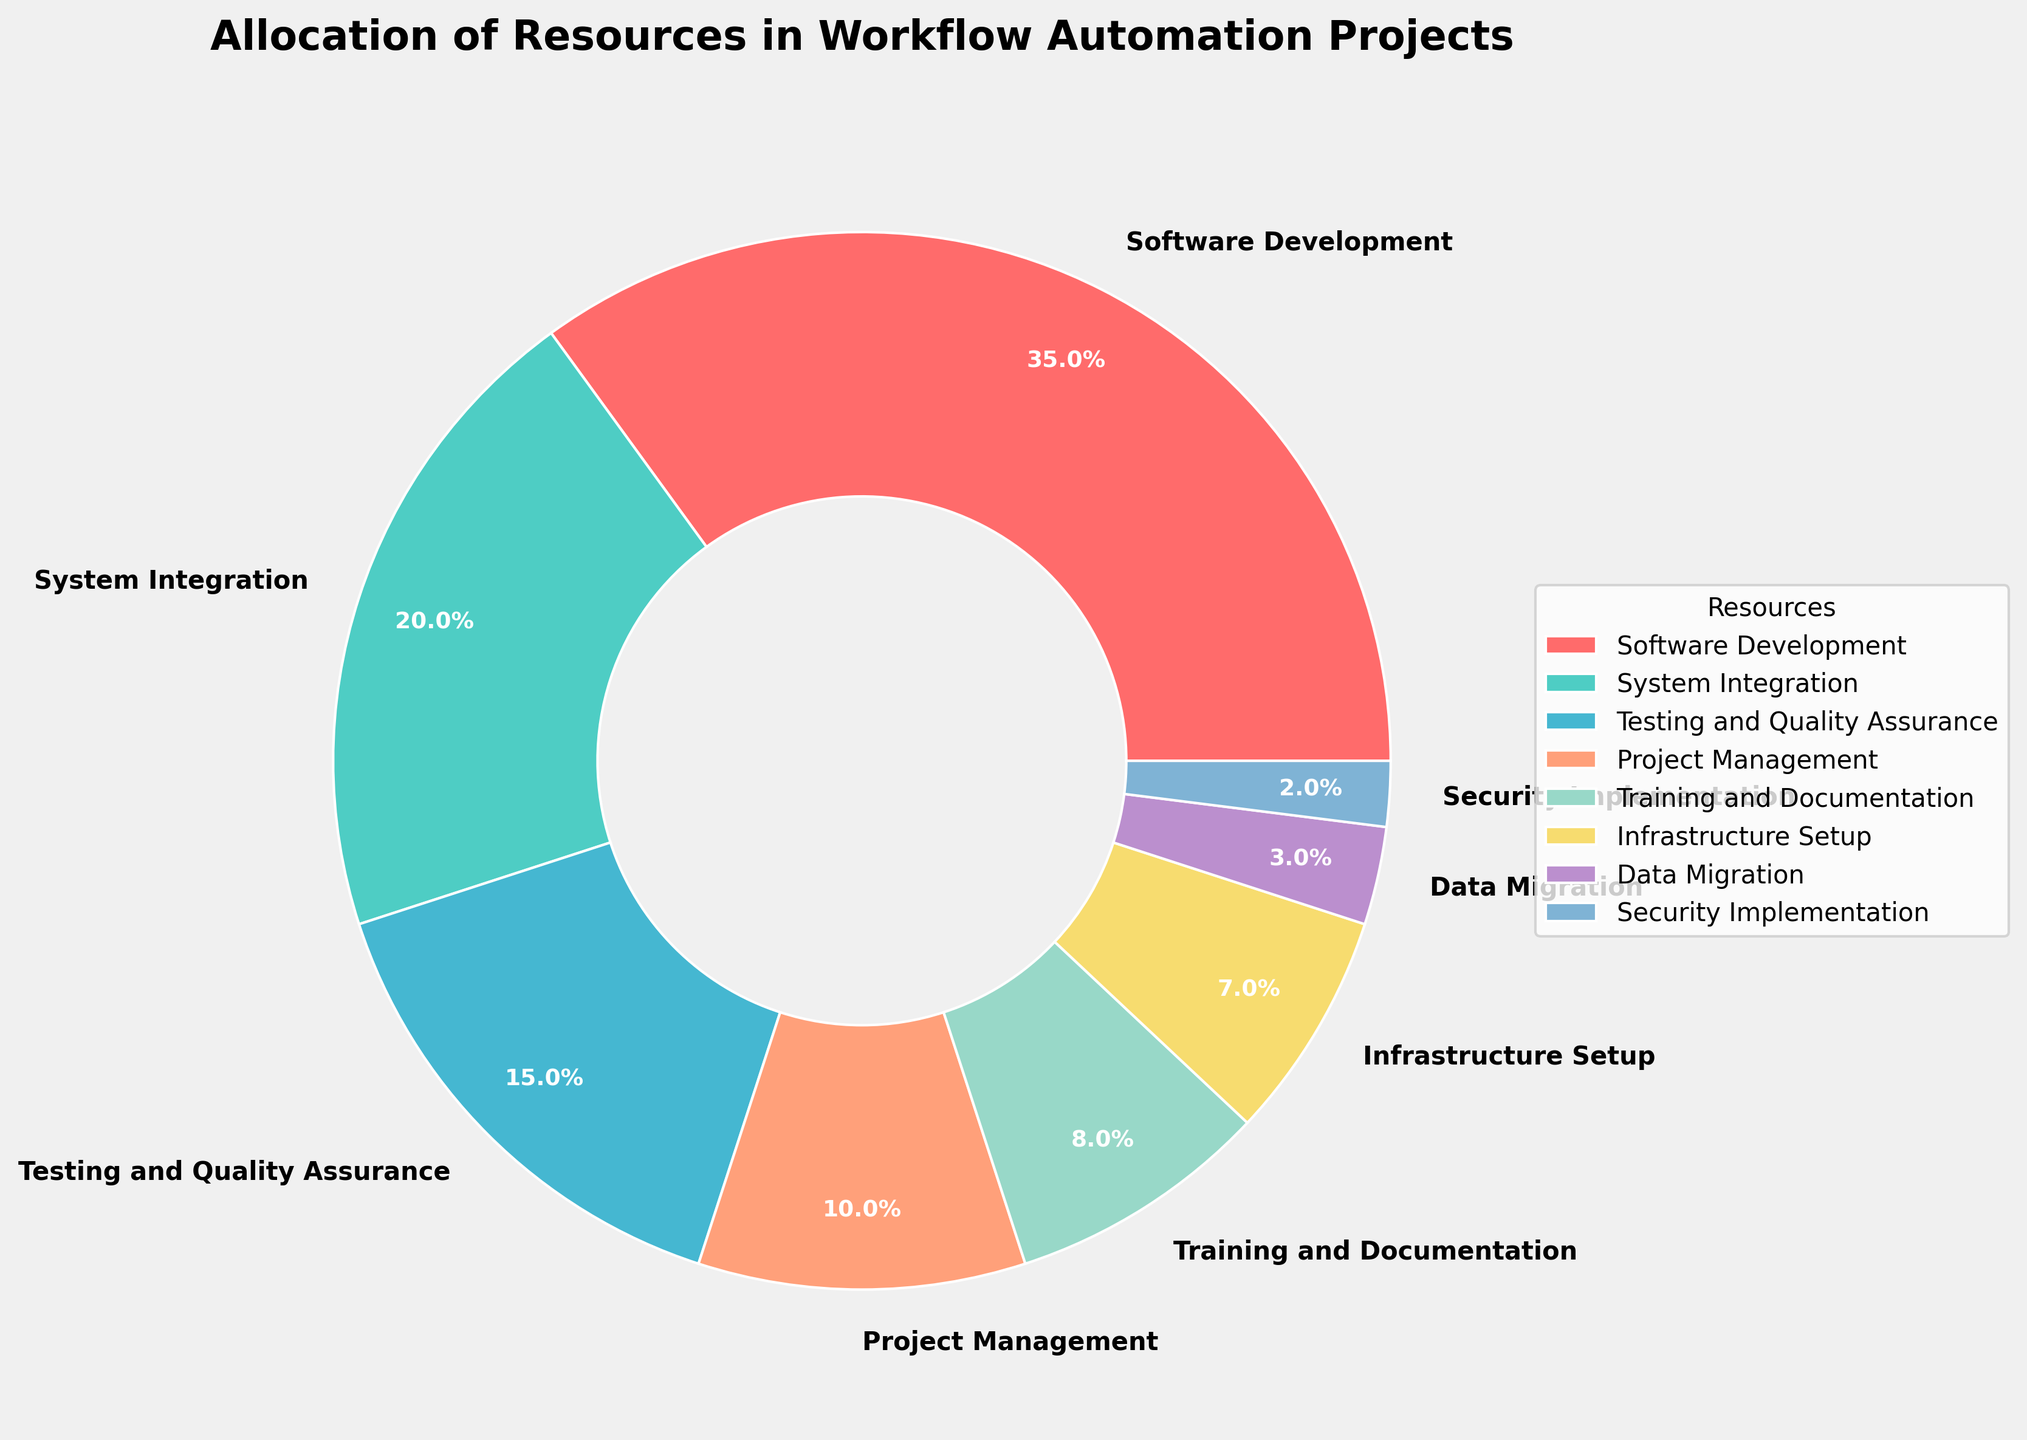What is the largest allocation of resources? The largest portion of the pie chart is labeled "Software Development" with a 35% allocation. Thus, referring to the visual slice and its label answers the question.
Answer: Software Development How much more percentage is allocated to Software Development compared to System Integration? From the pie chart, Software Development is allocated 35%, and System Integration is allocated 20%. The difference is calculated as 35% - 20%.
Answer: 15% What is the total percentage allocated to both Testing and Quality Assurance and Project Management combined? Testing and Quality Assurance is allocated 15%, and Project Management is allocated 10%. Their combined allocation is 15% + 10%.
Answer: 25% Which resource has the smallest allocation in the pie chart? The smallest slice in the pie chart is labeled "Security Implementation" with a 2% allocation. Thus, this slice and its label provide the answer.
Answer: Security Implementation How does the allocation for Training and Documentation compare to that for Infrastructure Setup? The pie chart shows Training and Documentation at 8% and Infrastructure Setup at 7%. Comparing the two values, Training and Documentation is higher.
Answer: Training and Documentation is higher Sum up the percentages allocated for Data Migration, Security Implementation, and Training and Documentation. The percentages are 3%, 2%, and 8%, respectively. The sum of these allocations is 3% + 2% + 8%.
Answer: 13% How many resources have an allocation percentage over 10%? From the pie chart, Software Development, System Integration, Testing and Quality Assurance, and Project Management are the resources. Visually checking their values, 35%, 20%, 15%, and 10% are all greater than 10%.
Answer: 4 resources Which resources have more than double the allocation of Infrastructure Setup? Infrastructure Setup is assigned 7%. Double of 7% is 14%. From the pie chart, Software Development (35%), System Integration (20%), and Testing and Quality Assurance (15%) all exceed 14%.
Answer: Software Development, System Integration, Testing and Quality Assurance Is the combined percentage for Project Management and Data Migration greater than that for Testing and Quality Assurance? Project Management is 10%, Data Migration is 3%, and Testing and Quality Assurance is 15%. The combined percentage of Project Management and Data Migration is 10% + 3% = 13%, which is less than 15%.
Answer: No Identify the resource represented by a pinkish-red slice. The resource corresponding to the pinkish-red slice in the pie chart is labeled "Software Development," which has a 35% allocation.
Answer: Software Development 